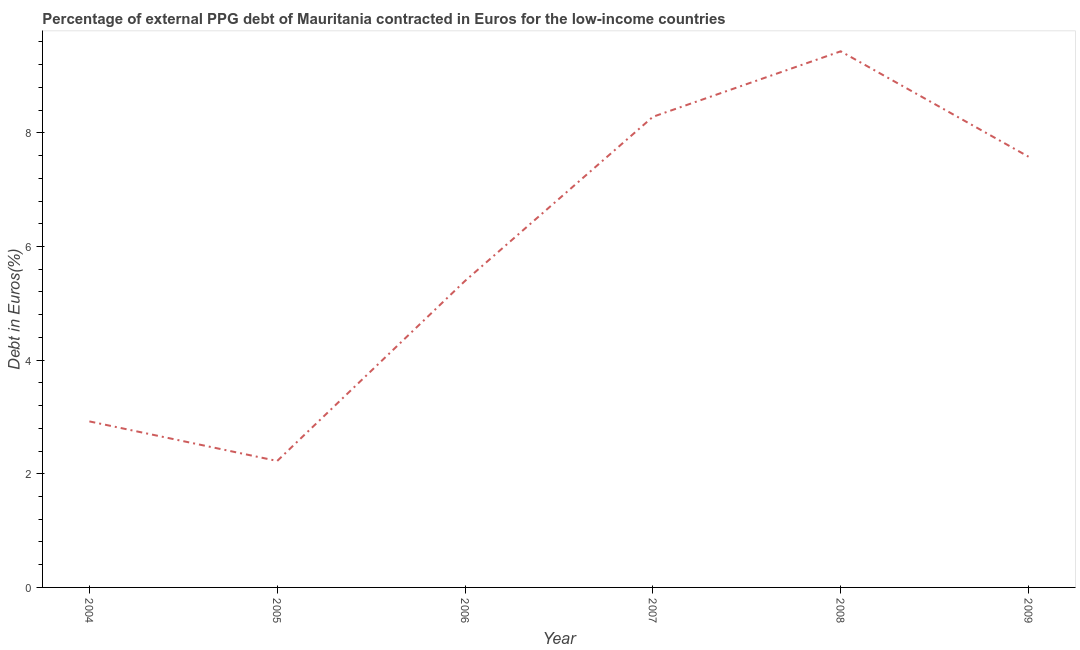What is the currency composition of ppg debt in 2007?
Give a very brief answer. 8.28. Across all years, what is the maximum currency composition of ppg debt?
Your answer should be very brief. 9.43. Across all years, what is the minimum currency composition of ppg debt?
Provide a succinct answer. 2.23. In which year was the currency composition of ppg debt maximum?
Your answer should be very brief. 2008. What is the sum of the currency composition of ppg debt?
Make the answer very short. 35.84. What is the difference between the currency composition of ppg debt in 2006 and 2009?
Make the answer very short. -2.19. What is the average currency composition of ppg debt per year?
Provide a short and direct response. 5.97. What is the median currency composition of ppg debt?
Offer a terse response. 6.49. What is the ratio of the currency composition of ppg debt in 2007 to that in 2009?
Provide a short and direct response. 1.09. Is the currency composition of ppg debt in 2005 less than that in 2007?
Provide a short and direct response. Yes. What is the difference between the highest and the second highest currency composition of ppg debt?
Make the answer very short. 1.15. What is the difference between the highest and the lowest currency composition of ppg debt?
Provide a short and direct response. 7.21. How many lines are there?
Offer a very short reply. 1. How many years are there in the graph?
Ensure brevity in your answer.  6. Does the graph contain grids?
Give a very brief answer. No. What is the title of the graph?
Your answer should be very brief. Percentage of external PPG debt of Mauritania contracted in Euros for the low-income countries. What is the label or title of the X-axis?
Provide a succinct answer. Year. What is the label or title of the Y-axis?
Offer a very short reply. Debt in Euros(%). What is the Debt in Euros(%) of 2004?
Your answer should be very brief. 2.92. What is the Debt in Euros(%) of 2005?
Give a very brief answer. 2.23. What is the Debt in Euros(%) in 2006?
Keep it short and to the point. 5.39. What is the Debt in Euros(%) in 2007?
Your answer should be very brief. 8.28. What is the Debt in Euros(%) of 2008?
Your response must be concise. 9.43. What is the Debt in Euros(%) in 2009?
Offer a very short reply. 7.58. What is the difference between the Debt in Euros(%) in 2004 and 2005?
Make the answer very short. 0.7. What is the difference between the Debt in Euros(%) in 2004 and 2006?
Offer a terse response. -2.47. What is the difference between the Debt in Euros(%) in 2004 and 2007?
Ensure brevity in your answer.  -5.36. What is the difference between the Debt in Euros(%) in 2004 and 2008?
Ensure brevity in your answer.  -6.51. What is the difference between the Debt in Euros(%) in 2004 and 2009?
Offer a terse response. -4.66. What is the difference between the Debt in Euros(%) in 2005 and 2006?
Provide a succinct answer. -3.17. What is the difference between the Debt in Euros(%) in 2005 and 2007?
Your answer should be very brief. -6.06. What is the difference between the Debt in Euros(%) in 2005 and 2008?
Ensure brevity in your answer.  -7.21. What is the difference between the Debt in Euros(%) in 2005 and 2009?
Provide a short and direct response. -5.35. What is the difference between the Debt in Euros(%) in 2006 and 2007?
Offer a very short reply. -2.89. What is the difference between the Debt in Euros(%) in 2006 and 2008?
Keep it short and to the point. -4.04. What is the difference between the Debt in Euros(%) in 2006 and 2009?
Provide a succinct answer. -2.19. What is the difference between the Debt in Euros(%) in 2007 and 2008?
Keep it short and to the point. -1.15. What is the difference between the Debt in Euros(%) in 2007 and 2009?
Keep it short and to the point. 0.7. What is the difference between the Debt in Euros(%) in 2008 and 2009?
Make the answer very short. 1.85. What is the ratio of the Debt in Euros(%) in 2004 to that in 2005?
Provide a succinct answer. 1.31. What is the ratio of the Debt in Euros(%) in 2004 to that in 2006?
Your answer should be very brief. 0.54. What is the ratio of the Debt in Euros(%) in 2004 to that in 2007?
Offer a very short reply. 0.35. What is the ratio of the Debt in Euros(%) in 2004 to that in 2008?
Offer a terse response. 0.31. What is the ratio of the Debt in Euros(%) in 2004 to that in 2009?
Your answer should be very brief. 0.39. What is the ratio of the Debt in Euros(%) in 2005 to that in 2006?
Offer a terse response. 0.41. What is the ratio of the Debt in Euros(%) in 2005 to that in 2007?
Offer a very short reply. 0.27. What is the ratio of the Debt in Euros(%) in 2005 to that in 2008?
Ensure brevity in your answer.  0.24. What is the ratio of the Debt in Euros(%) in 2005 to that in 2009?
Your answer should be compact. 0.29. What is the ratio of the Debt in Euros(%) in 2006 to that in 2007?
Provide a succinct answer. 0.65. What is the ratio of the Debt in Euros(%) in 2006 to that in 2008?
Make the answer very short. 0.57. What is the ratio of the Debt in Euros(%) in 2006 to that in 2009?
Keep it short and to the point. 0.71. What is the ratio of the Debt in Euros(%) in 2007 to that in 2008?
Your answer should be compact. 0.88. What is the ratio of the Debt in Euros(%) in 2007 to that in 2009?
Make the answer very short. 1.09. What is the ratio of the Debt in Euros(%) in 2008 to that in 2009?
Provide a short and direct response. 1.25. 